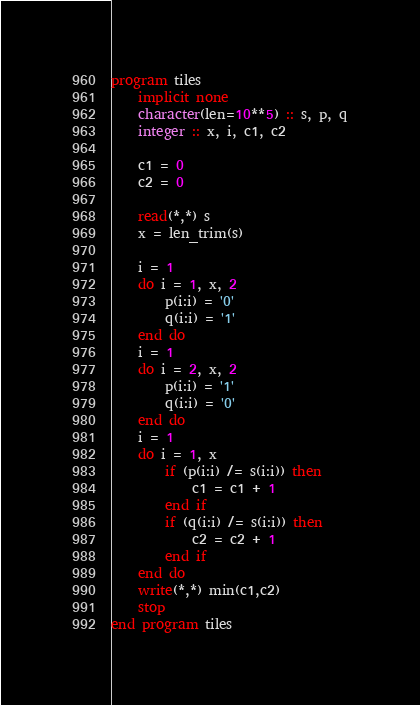Convert code to text. <code><loc_0><loc_0><loc_500><loc_500><_FORTRAN_>program tiles
	implicit none
	character(len=10**5) :: s, p, q
	integer :: x, i, c1, c2
    
	c1 = 0
    c2 = 0
    
	read(*,*) s    
	x = len_trim(s)
    
    i = 1
	do i = 1, x, 2
		p(i:i) = '0'
        q(i:i) = '1'
    end do
    i = 1
    do i = 2, x, 2
    	p(i:i) = '1'
        q(i:i) = '0'
    end do 
	i = 1    
    do i = 1, x
    	if (p(i:i) /= s(i:i)) then
        	c1 = c1 + 1
        end if
        if (q(i:i) /= s(i:i)) then
        	c2 = c2 + 1
        end if
    end do
    write(*,*) min(c1,c2)
    stop
end program tiles</code> 